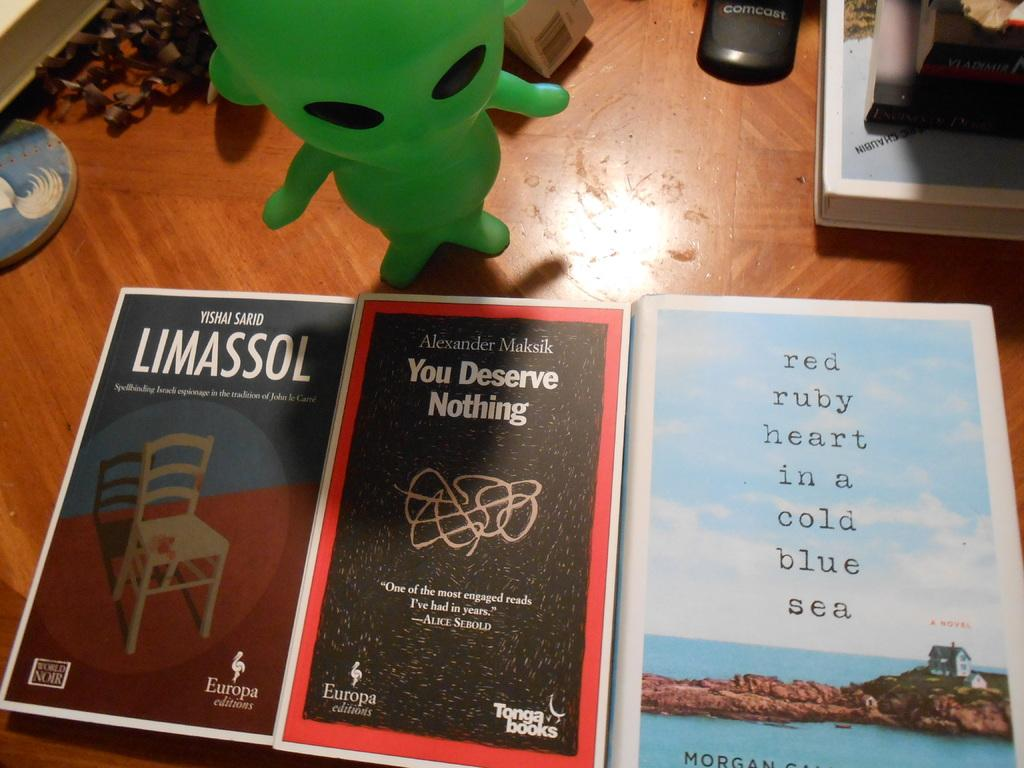<image>
Relay a brief, clear account of the picture shown. Book with a chair on it titled Limassol on a table next to some other books. 